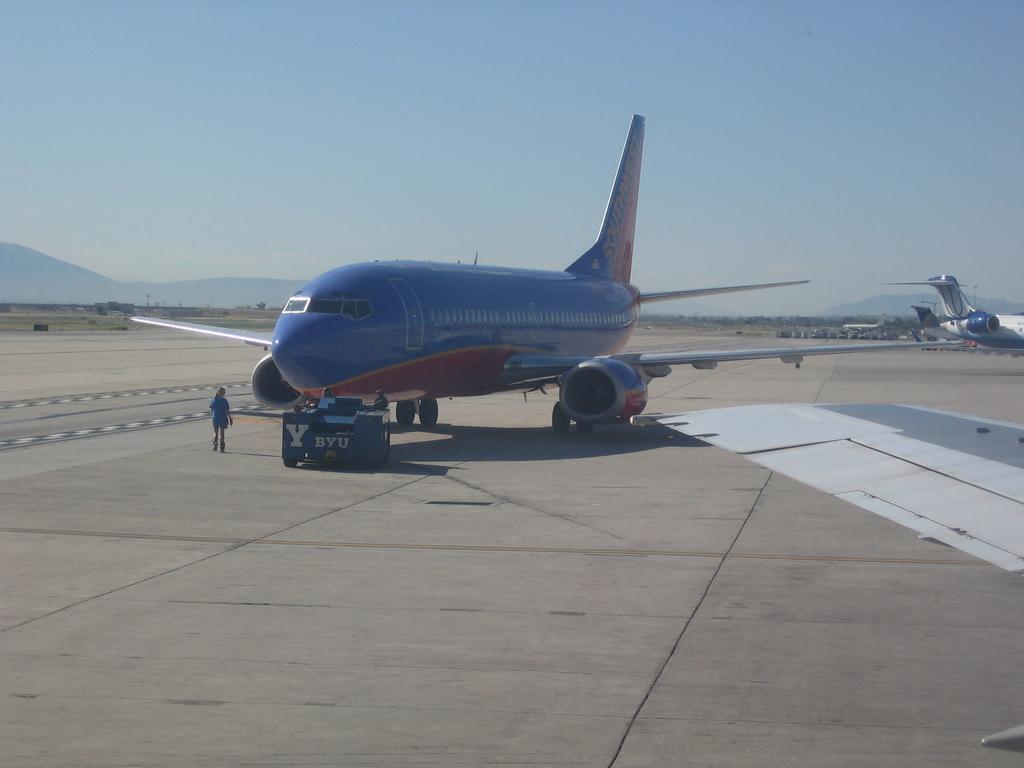Which airline is this?
Offer a very short reply. Southwest. 